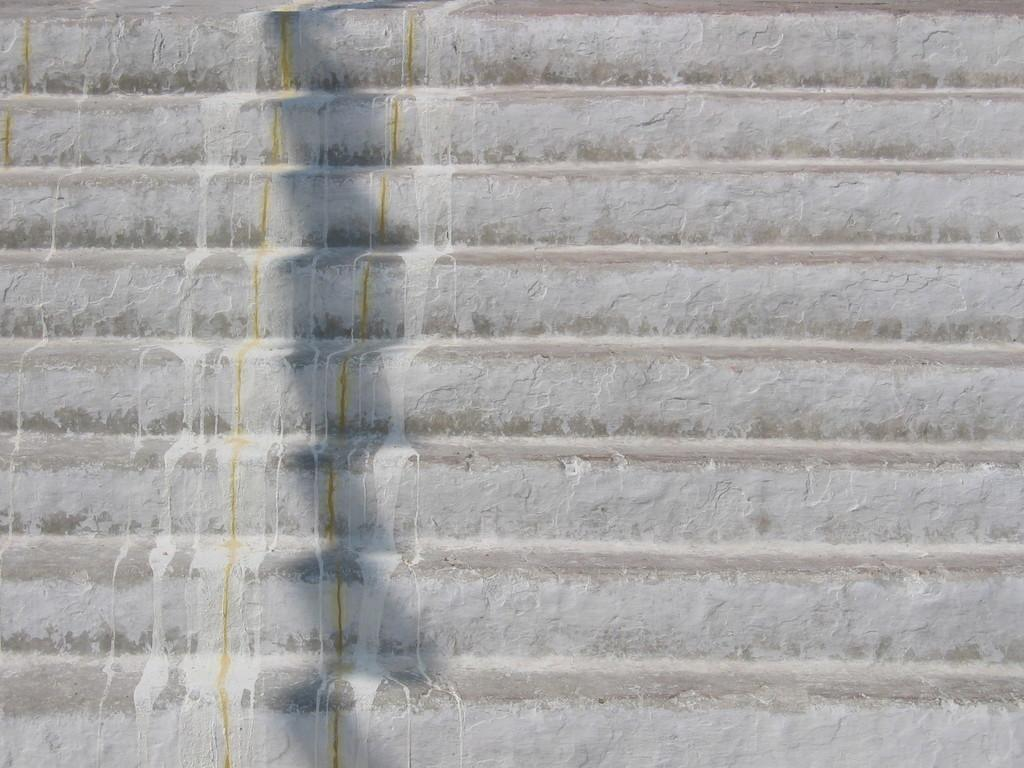What type of structure is present in the image? There are stairs in the image. Can you describe the stairs in more detail? Unfortunately, the provided facts do not offer any additional details about the stairs. Are there any other structures or objects visible in the image? The given facts do not mention any other structures or objects in the image. What type of clouds can be seen in the image? There are no clouds present in the image, as it only features stairs. Can you hear the voice of the person who built the stairs in the image? There is no reference to a person who built the stairs or any sound in the image, so it is not possible to answer that question. 